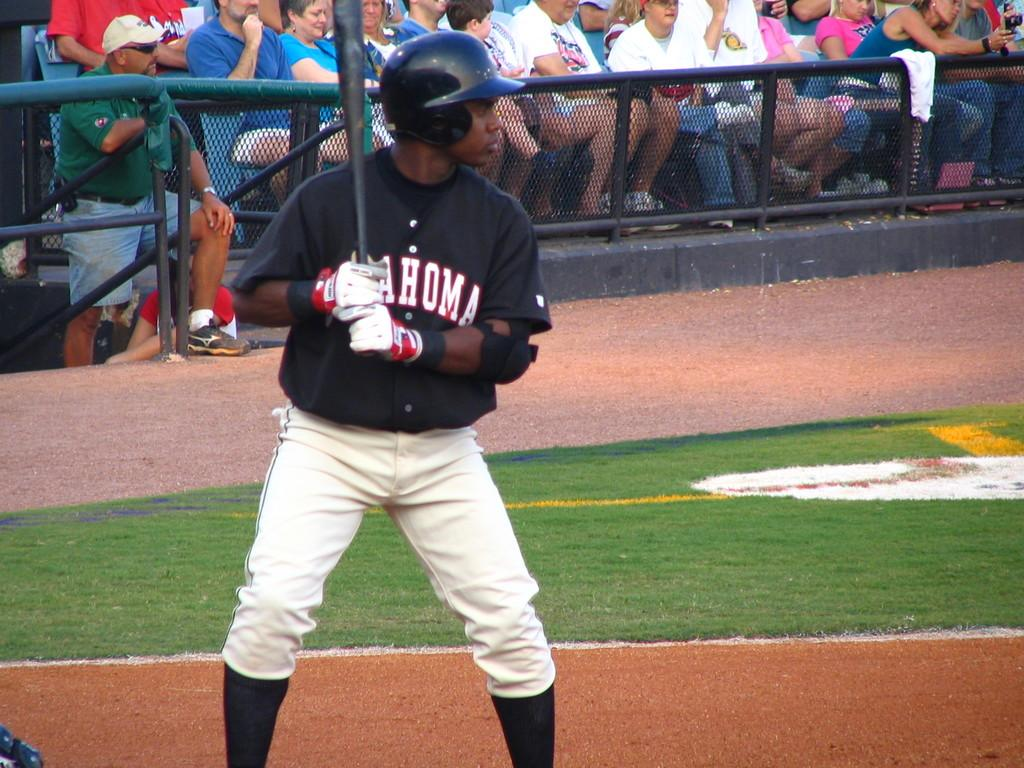<image>
Create a compact narrative representing the image presented. A man in an Oklahoma uniform prepares to hit the ball. 